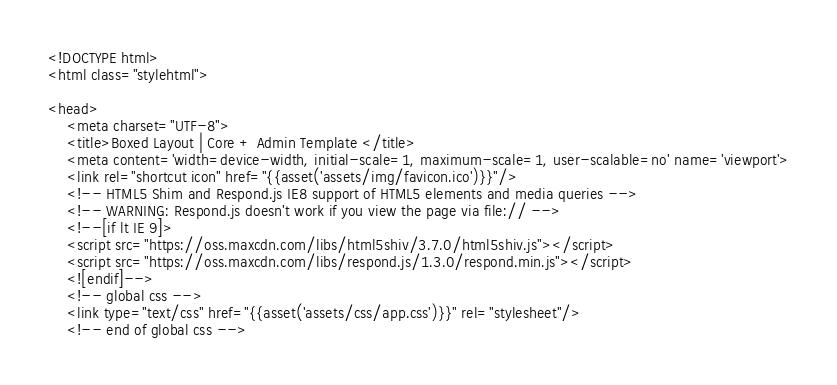Convert code to text. <code><loc_0><loc_0><loc_500><loc_500><_PHP_><!DOCTYPE html>
<html class="stylehtml">

<head>
    <meta charset="UTF-8">
    <title>Boxed Layout | Core + Admin Template </title>
    <meta content='width=device-width, initial-scale=1, maximum-scale=1, user-scalable=no' name='viewport'>
    <link rel="shortcut icon" href="{{asset('assets/img/favicon.ico')}}"/>
    <!-- HTML5 Shim and Respond.js IE8 support of HTML5 elements and media queries -->
    <!-- WARNING: Respond.js doesn't work if you view the page via file:// -->
    <!--[if lt IE 9]>
    <script src="https://oss.maxcdn.com/libs/html5shiv/3.7.0/html5shiv.js"></script>
    <script src="https://oss.maxcdn.com/libs/respond.js/1.3.0/respond.min.js"></script>
    <![endif]-->
    <!-- global css -->
    <link type="text/css" href="{{asset('assets/css/app.css')}}" rel="stylesheet"/>
    <!-- end of global css --></code> 